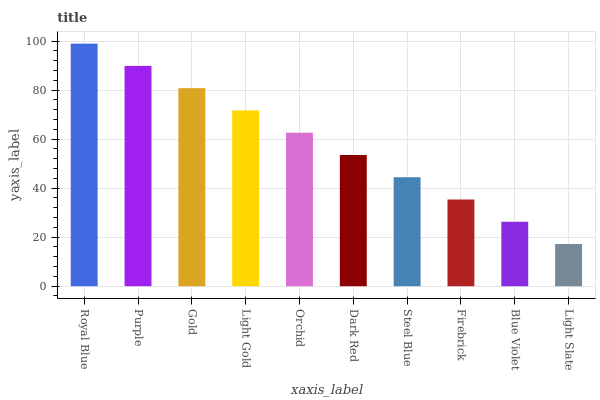Is Light Slate the minimum?
Answer yes or no. Yes. Is Royal Blue the maximum?
Answer yes or no. Yes. Is Purple the minimum?
Answer yes or no. No. Is Purple the maximum?
Answer yes or no. No. Is Royal Blue greater than Purple?
Answer yes or no. Yes. Is Purple less than Royal Blue?
Answer yes or no. Yes. Is Purple greater than Royal Blue?
Answer yes or no. No. Is Royal Blue less than Purple?
Answer yes or no. No. Is Orchid the high median?
Answer yes or no. Yes. Is Dark Red the low median?
Answer yes or no. Yes. Is Light Slate the high median?
Answer yes or no. No. Is Purple the low median?
Answer yes or no. No. 